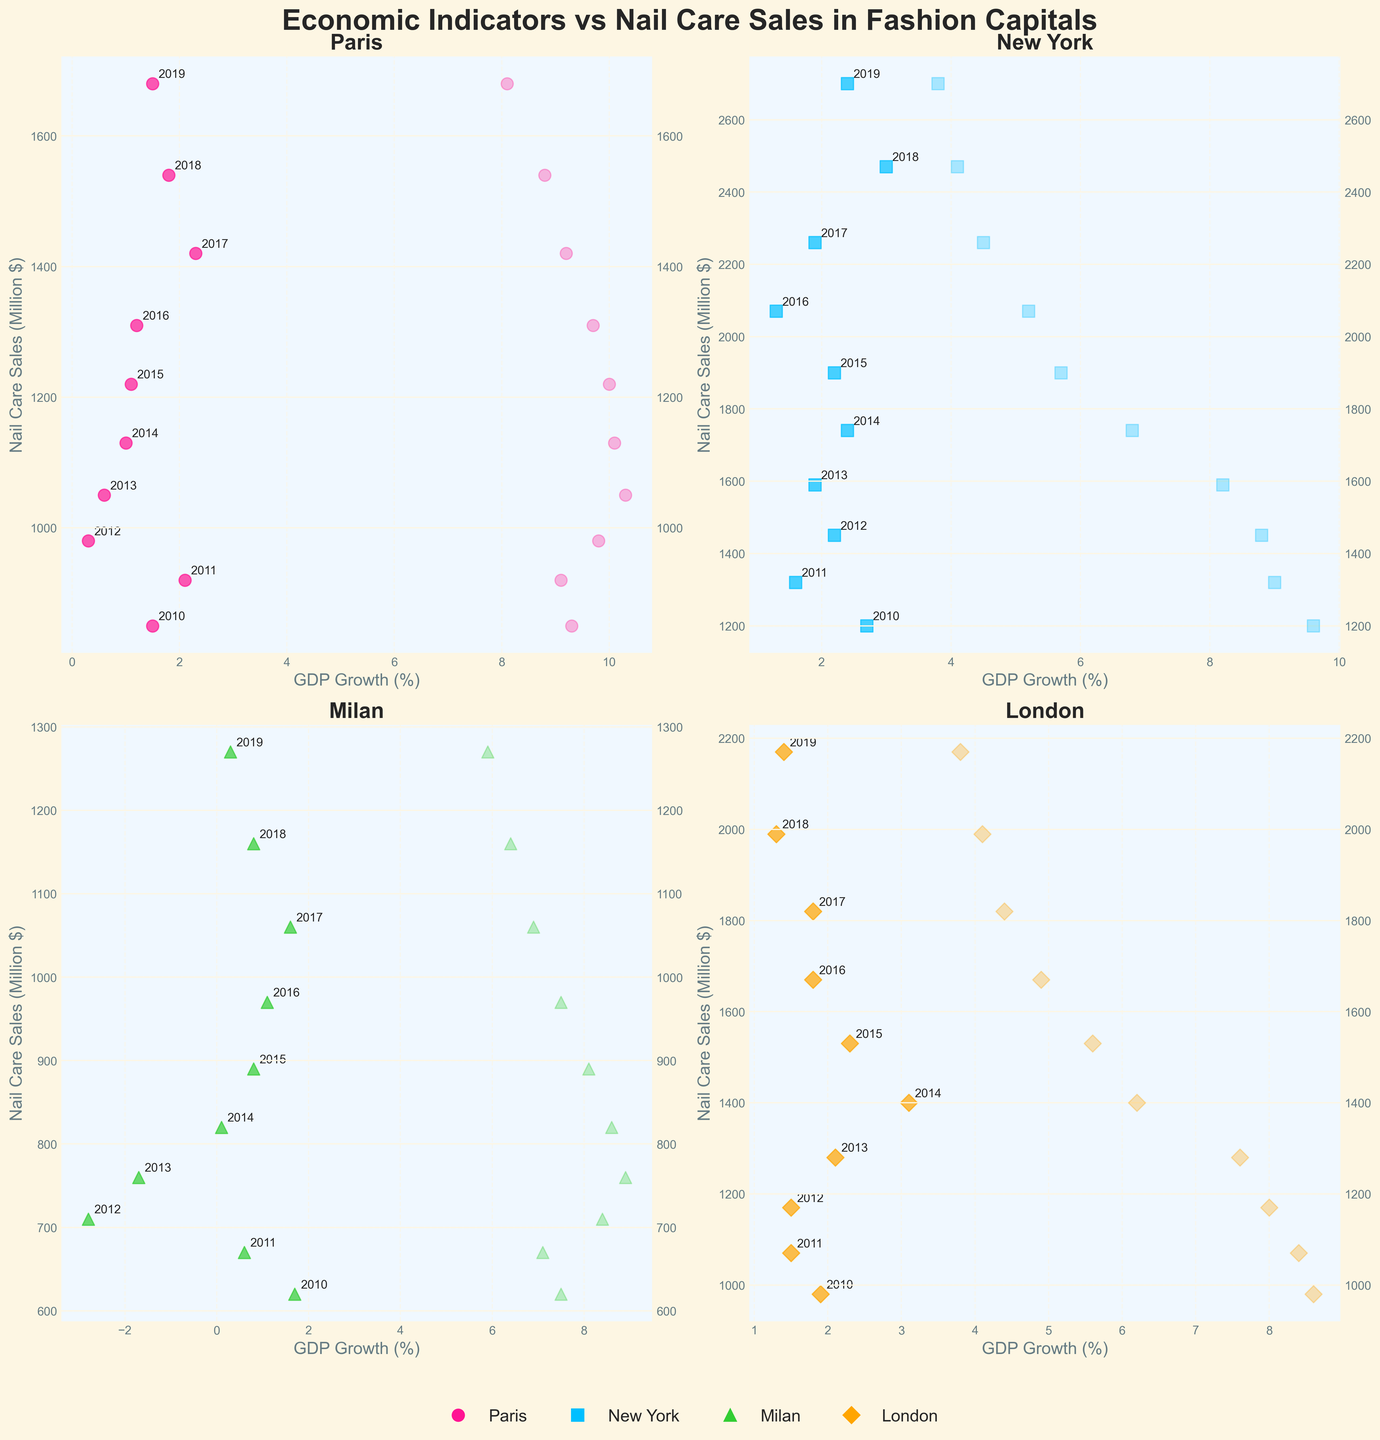What city shows the highest Nail Care Sales in 2019? By examining the four subplots, look for the highest Nail Care Sales value in the year 2019 across all cities. The subplot for each city provides these details.
Answer: New York In which city and year do we see the lowest GDP Growth? Locate the lowest point on the x-axis representing GDP Growth for each city's subplot. Compare these values along with the respective years.
Answer: Milan, 2012 Which city has the most consistent increase in Nail Care Sales over the years? Observe the overall trend in Nail Care Sales data points in each subplot. The city where the sales points rise steadily indicates consistency.
Answer: Paris How does the Unemployment Rate affect Nail Care Sales in Milan over the years? Focus on Milan's subplot and note the positioning of Nail Care Sales data points between the two y-axes (one indicating Unemployment Rate). Identify any visual trends of Nail Care Sales as Unemployment Rate changes.
Answer: Higher Unemployment Rates correlate with lower sales Which city shows a noticeable drop in Unemployment Rate from 2010 to 2019? Look at the visual indicator (scattered points) for Unemployment Rate on each city's subplot. Identify the trend and compare the positions from start to end (2010 to 2019).
Answer: New York 